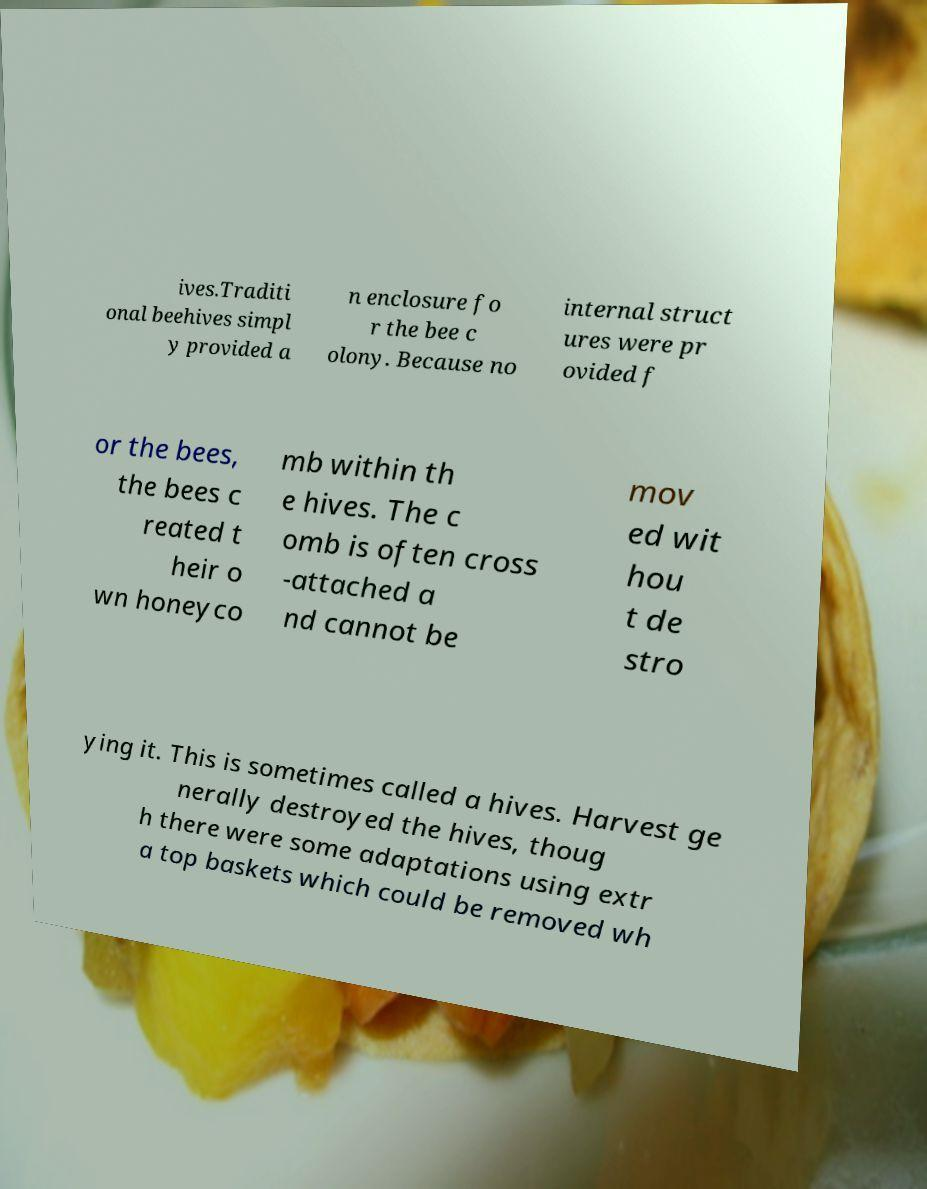Could you extract and type out the text from this image? ives.Traditi onal beehives simpl y provided a n enclosure fo r the bee c olony. Because no internal struct ures were pr ovided f or the bees, the bees c reated t heir o wn honeyco mb within th e hives. The c omb is often cross -attached a nd cannot be mov ed wit hou t de stro ying it. This is sometimes called a hives. Harvest ge nerally destroyed the hives, thoug h there were some adaptations using extr a top baskets which could be removed wh 